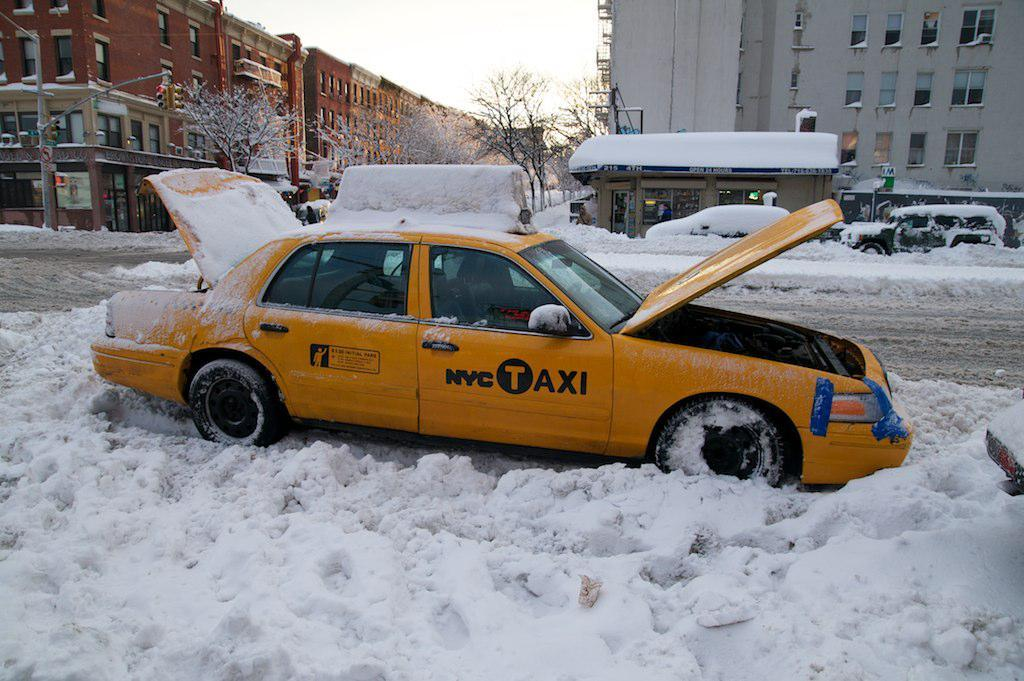Provide a one-sentence caption for the provided image. The yellow taxi here is from New York City. 